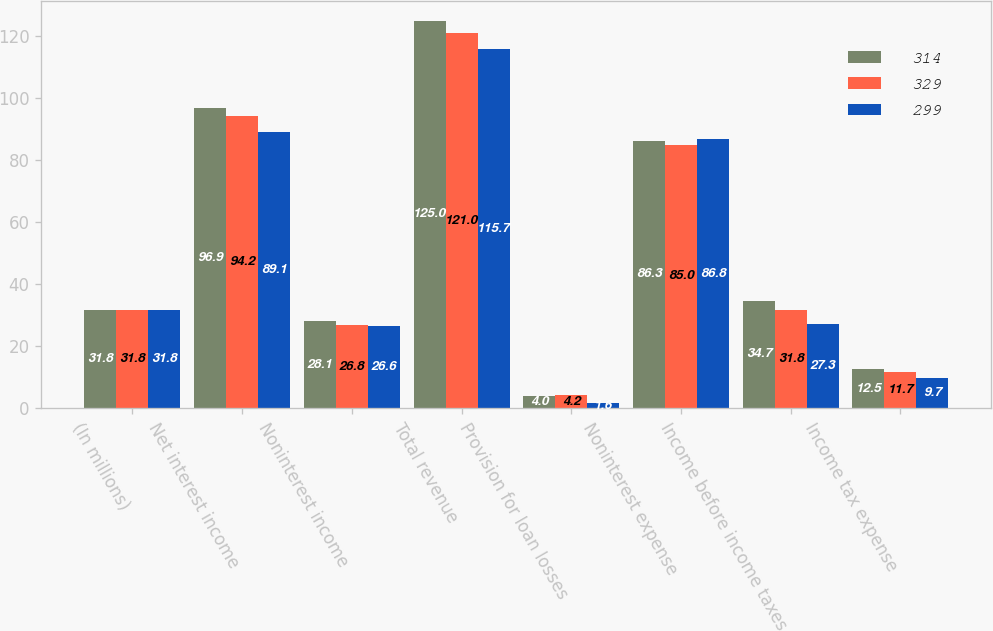Convert chart. <chart><loc_0><loc_0><loc_500><loc_500><stacked_bar_chart><ecel><fcel>(In millions)<fcel>Net interest income<fcel>Noninterest income<fcel>Total revenue<fcel>Provision for loan losses<fcel>Noninterest expense<fcel>Income before income taxes<fcel>Income tax expense<nl><fcel>314<fcel>31.8<fcel>96.9<fcel>28.1<fcel>125<fcel>4<fcel>86.3<fcel>34.7<fcel>12.5<nl><fcel>329<fcel>31.8<fcel>94.2<fcel>26.8<fcel>121<fcel>4.2<fcel>85<fcel>31.8<fcel>11.7<nl><fcel>299<fcel>31.8<fcel>89.1<fcel>26.6<fcel>115.7<fcel>1.6<fcel>86.8<fcel>27.3<fcel>9.7<nl></chart> 